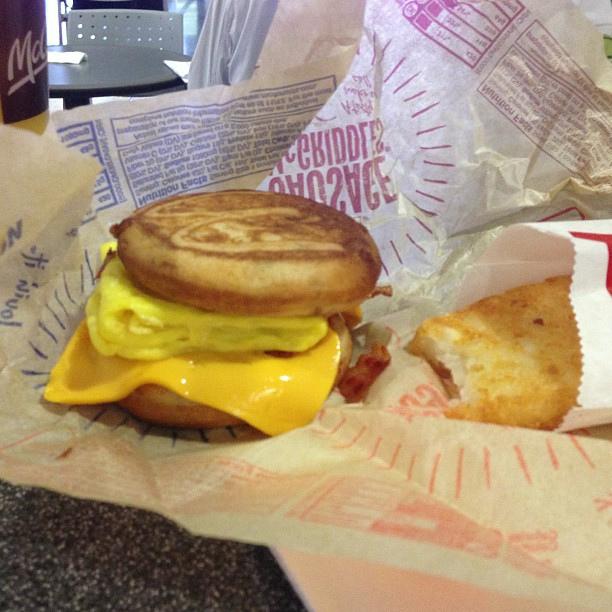Is there a bite taken out of the sandwich yet?
Be succinct. No. What is in the sandwich?
Write a very short answer. Mcgriddle. What fast food place did this food come from?
Concise answer only. Mcdonald's. Does the sandwich have bacon?
Keep it brief. Yes. 